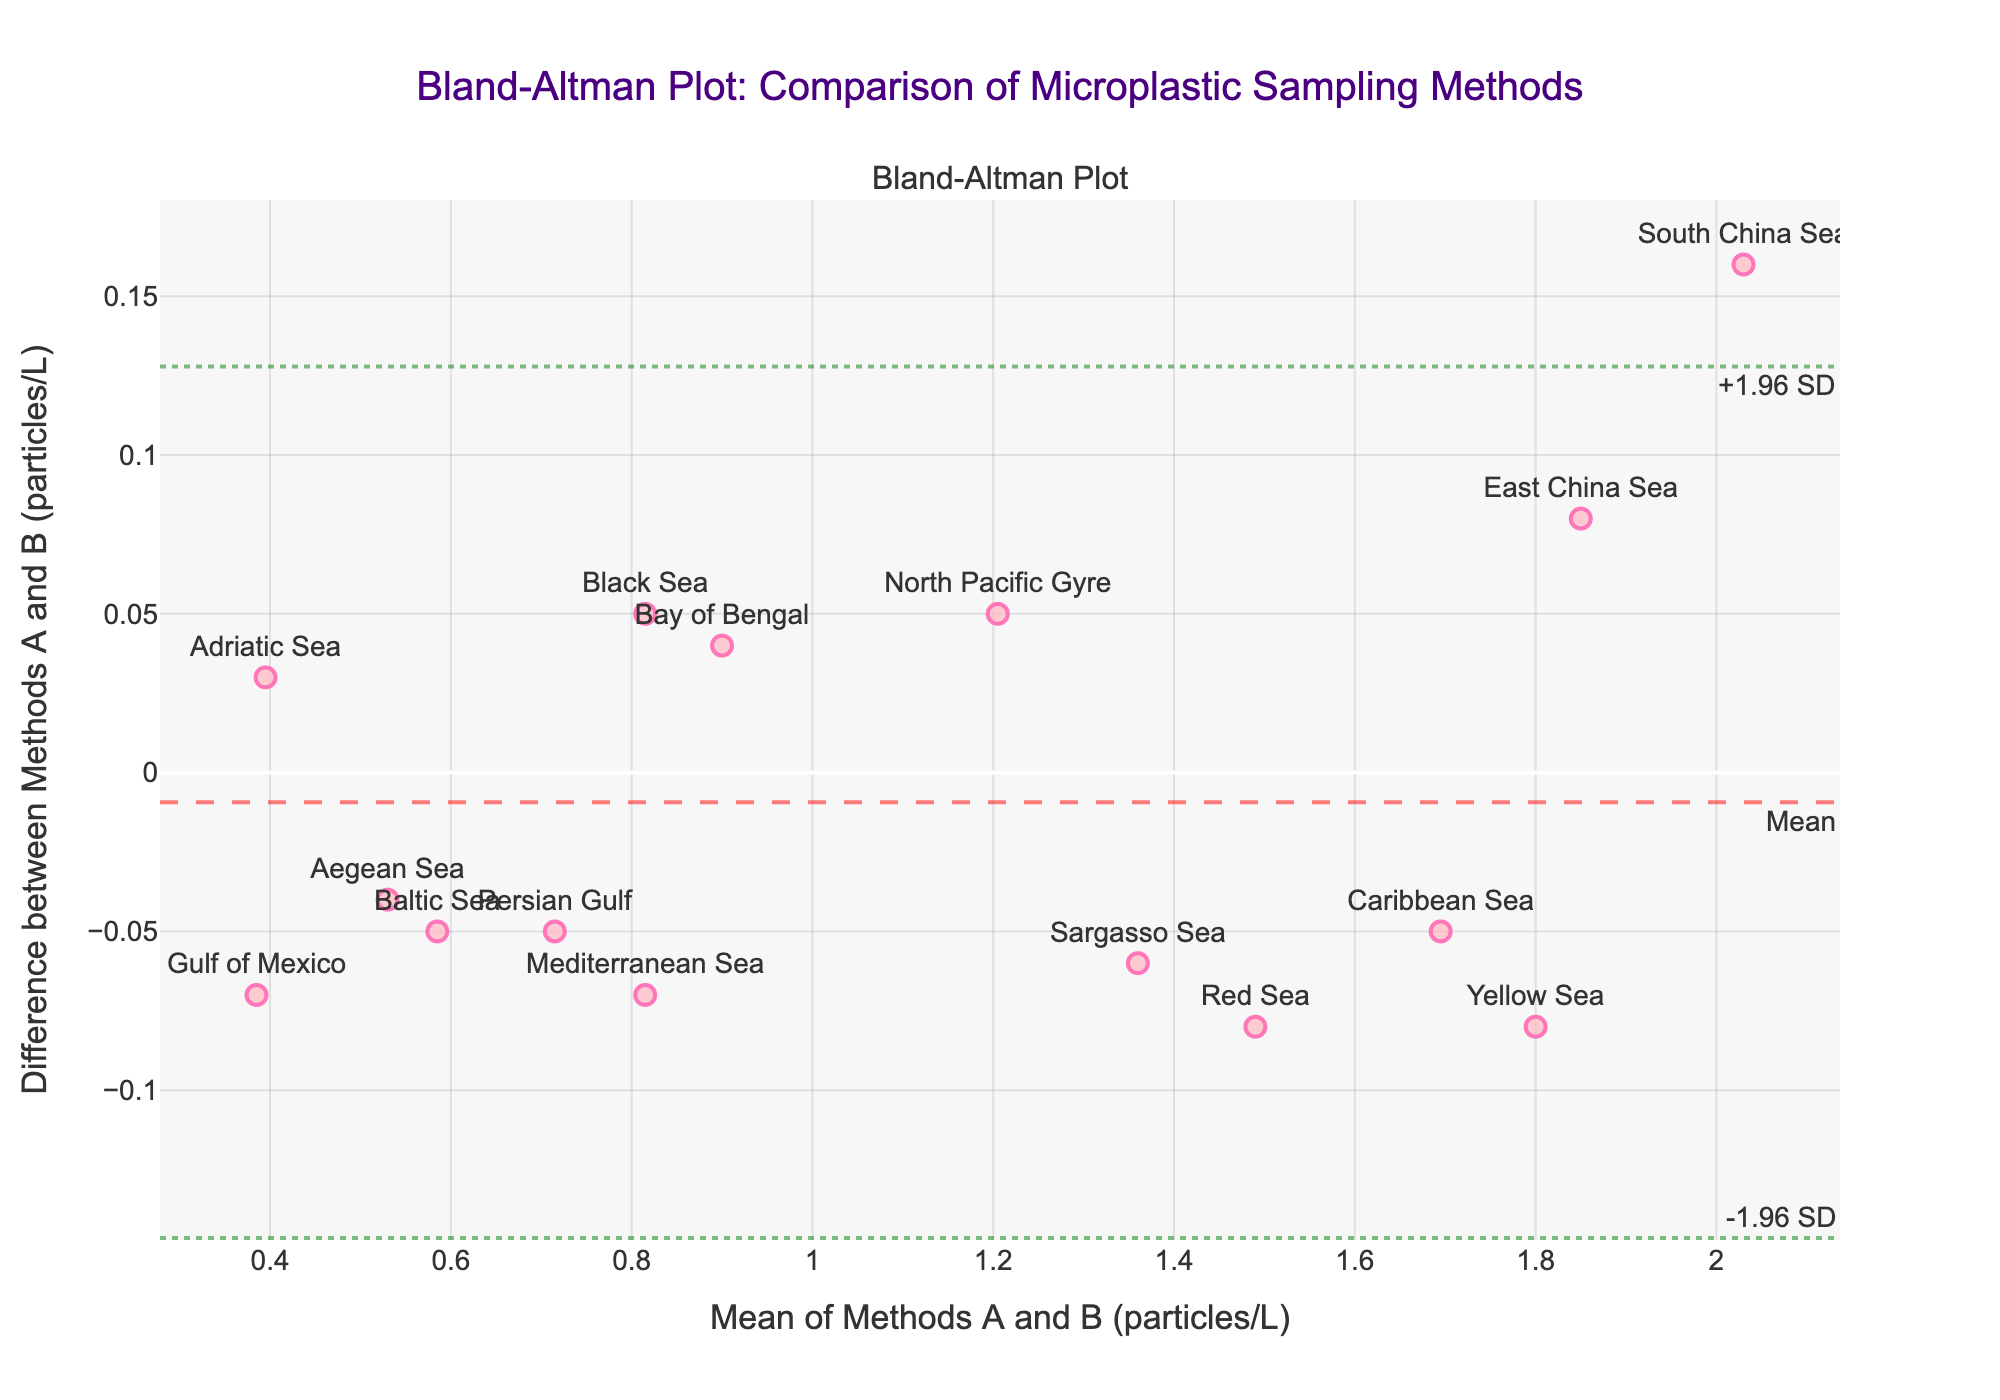What is the title of the plot? The title of the plot is displayed at the top of the figure. It reads "Bland-Altman Plot: Comparison of Microplastic Sampling Methods”.
Answer: Bland-Altman Plot: Comparison of Microplastic Sampling Methods How many data points are plotted on the figure? Count each marker or point reflected on the plot. Each location is represented by a single marker. In total, there are 15 markers on the plot.
Answer: 15 What does the x-axis represent? The x-axis label provides the information about what it represents. It is labeled as “Mean of Methods A and B (particles/L)”.
Answer: Mean of Methods A and B (particles/L) What does the y-axis represent? The y-axis label provides the information about what it represents. It is labeled as “Difference between Methods A and B (particles/L)”.
Answer: Difference between Methods A and B (particles/L) Which location has the highest mean value of microplastic particles/L? The data point to the far right on the x-axis represents the highest mean value of microplastic particles/L. The respective hover text identifies this location as the South China Sea.
Answer: South China Sea What are the limits of agreement on the plot? The limits of agreement are shown by the dotted lines on the plot. The upper limit is labeled as "+1.96 SD" and the lower limit as "-1.96 SD". These lines correspond to the areas where most of the data points fall within the set standard deviations around the mean difference.
Answer: Upper: +1.96 SD, Lower: -1.96 SD What is the mean difference between the measurements of the two methods? The mean difference between the two methods is indicated by the dashed line labeled “Mean” on the plot.
Answer: Mean difference (exact value not visible, but represented by the dashed line) Are there any points falling outside the limits of agreement? By visually inspecting the plot, we see that all points lie within the dotted lines labeled as the limits of agreement (+1.96 SD and -1.96 SD).
Answer: No Which location has the largest positive difference in measurements between Method A and Method B? The data point with the highest value on the y-axis represents the largest positive difference between Method A and Method B. The hover text identifies this location as the Mediterranean Sea.
Answer: Mediterranean Sea Which location has a negative difference in its measurements and a mean value around 1.50 particles/L? By looking at the data point located around 1.50 on the x-axis and below the zero-line on the y-axis, the respective hover text identifies this location as the Red Sea.
Answer: Red Sea What does the color of the markers signify in the plot? The color of the markers appears to be selected to enhance visibility but does not encode additional information. Markers are pink with a red outline.
Answer: No specific significance 